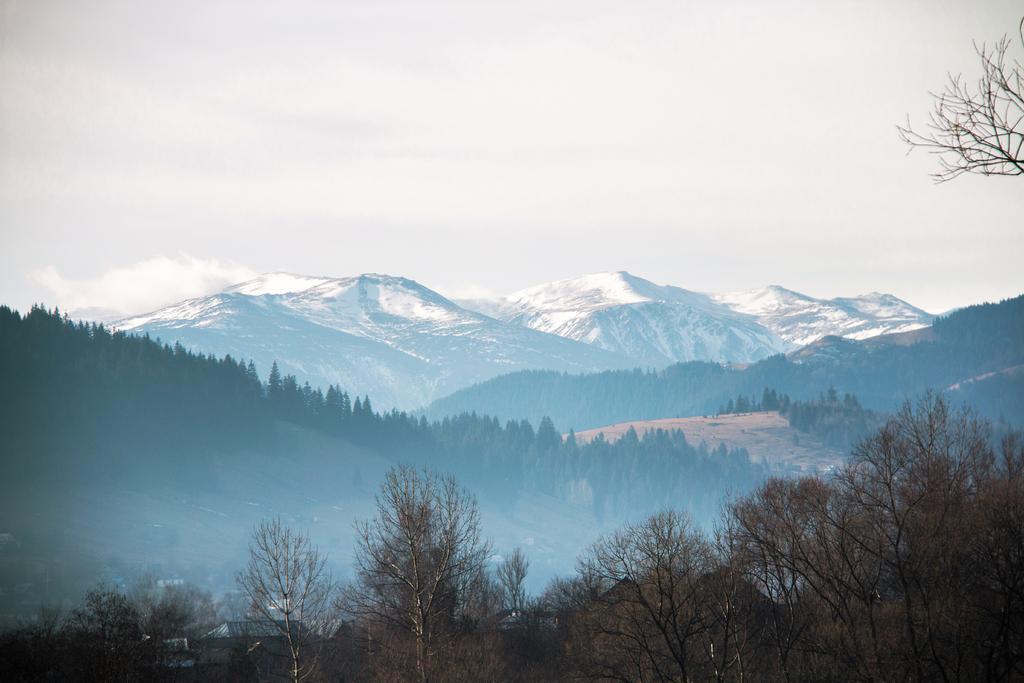Could you give a brief overview of what you see in this image? In this image there are trees at front. At the background there are mountains and sky. 